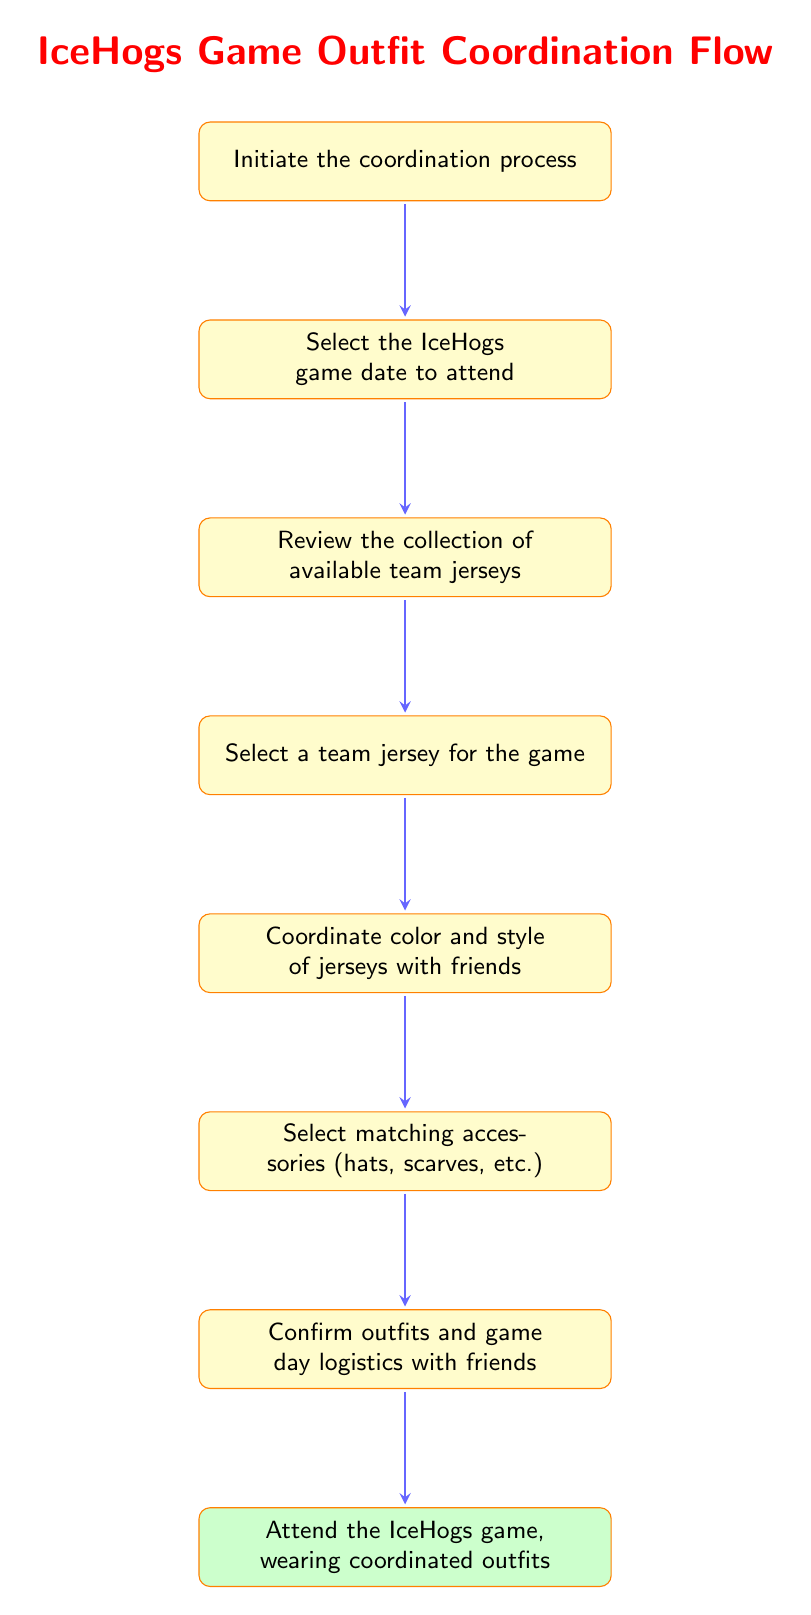What is the first step in the coordination process? The diagram indicates that the first step in the coordination process is to "Initiate the coordination process".
Answer: Initiate the coordination process How many nodes are in the diagram? By counting the individual steps laid out in the flow chart, there are a total of 8 nodes.
Answer: 8 What is the final step before attending the game? The final step before attending the game is to "Confirm outfits and game day logistics with friends".
Answer: Confirm outfits and game day logistics with friends Which node directly follows "Choose_Accessories"? The node that directly follows "Choose_Accessories" is "Finalize_Details".
Answer: Finalize_Details What is the last action that takes place in the flow? The last action that takes place in the flow is to "Attend the IceHogs game, wearing coordinated outfits".
Answer: Attend the IceHogs game, wearing coordinated outfits What is the third step in the process? The third step in the coordination process is "Review the collection of available team jerseys".
Answer: Review the collection of available team jerseys What process comes after selecting a jersey? After selecting a jersey, the next step is to "Coordinate color and style of jerseys with friends".
Answer: Coordinate color and style of jerseys with friends Which two nodes are connected directly by an arrow after "Select_Jersey"? The two nodes connected directly by an arrow after "Select_Jersey" are "Coordinate_with_Friends" and "Select_Accessories".
Answer: Coordinate_with_Friends and Select_Accessories 